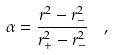<formula> <loc_0><loc_0><loc_500><loc_500>\alpha = \frac { r ^ { 2 } - r _ { - } ^ { 2 } } { r _ { + } ^ { 2 } - r _ { - } ^ { 2 } } \ \ ,</formula> 